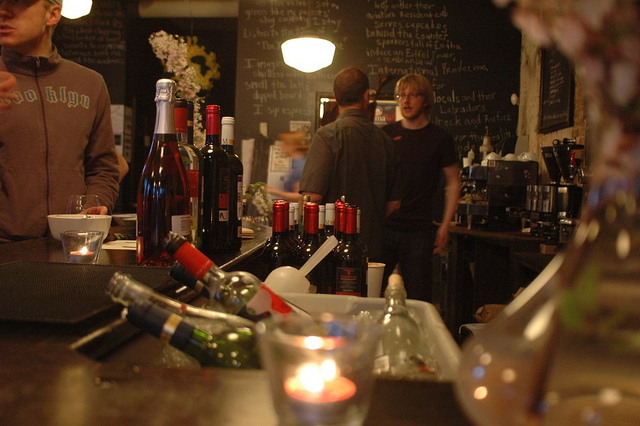What does the person on the left's hoodie read? It's not entirely clear from the image what exactly the text on the hoodie reads due to the resolution and angle. However, it appears to include some kind of bold text possibly related to a name or a brand. 